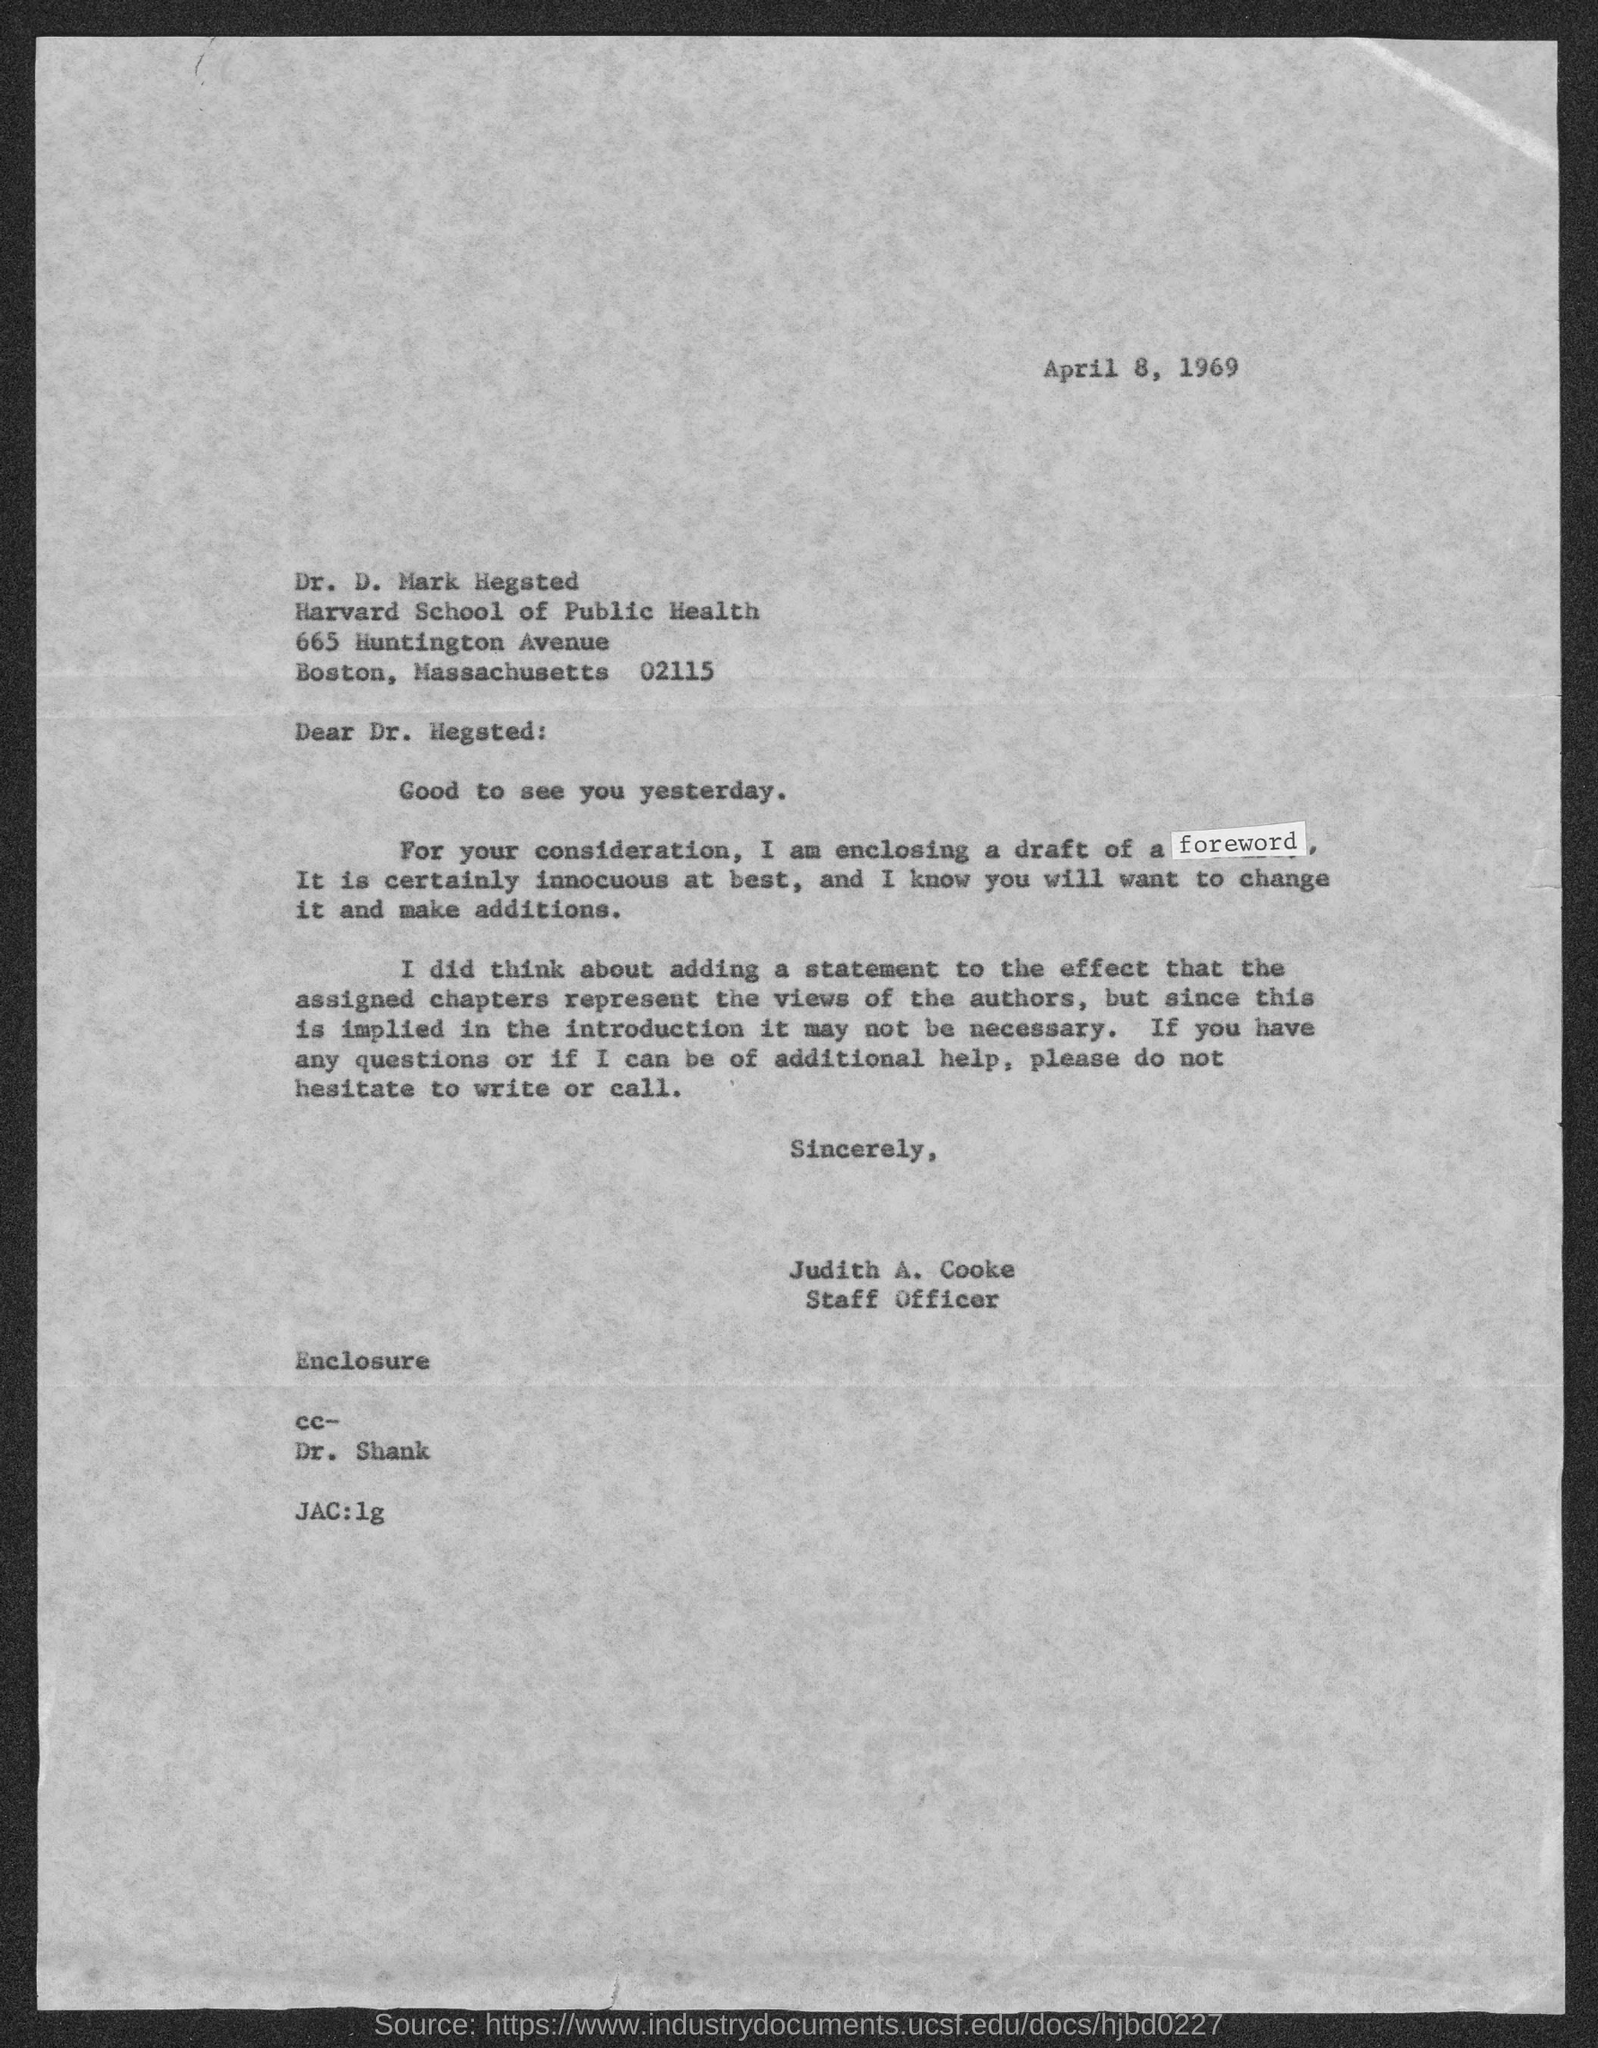What is the date mentioned in the given letter ?
Ensure brevity in your answer.  April 8, 1969. From whom this letter was delivered ?
Your answer should be compact. Judith A. Cooke. What is the designation of judith a. cooke ?
Your answer should be very brief. Staff officer. To which department dr. d. mark hegsted belongs to ?
Provide a succinct answer. Harvard school of public health. 